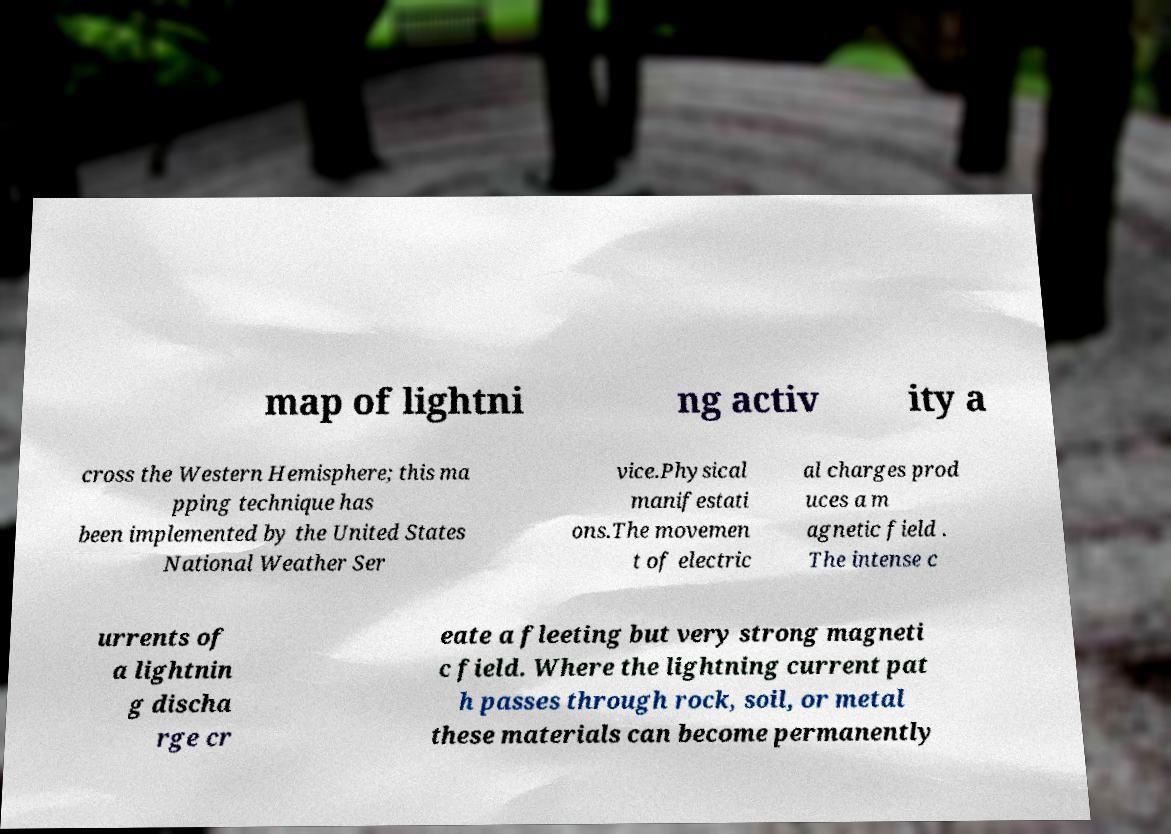Could you extract and type out the text from this image? map of lightni ng activ ity a cross the Western Hemisphere; this ma pping technique has been implemented by the United States National Weather Ser vice.Physical manifestati ons.The movemen t of electric al charges prod uces a m agnetic field . The intense c urrents of a lightnin g discha rge cr eate a fleeting but very strong magneti c field. Where the lightning current pat h passes through rock, soil, or metal these materials can become permanently 